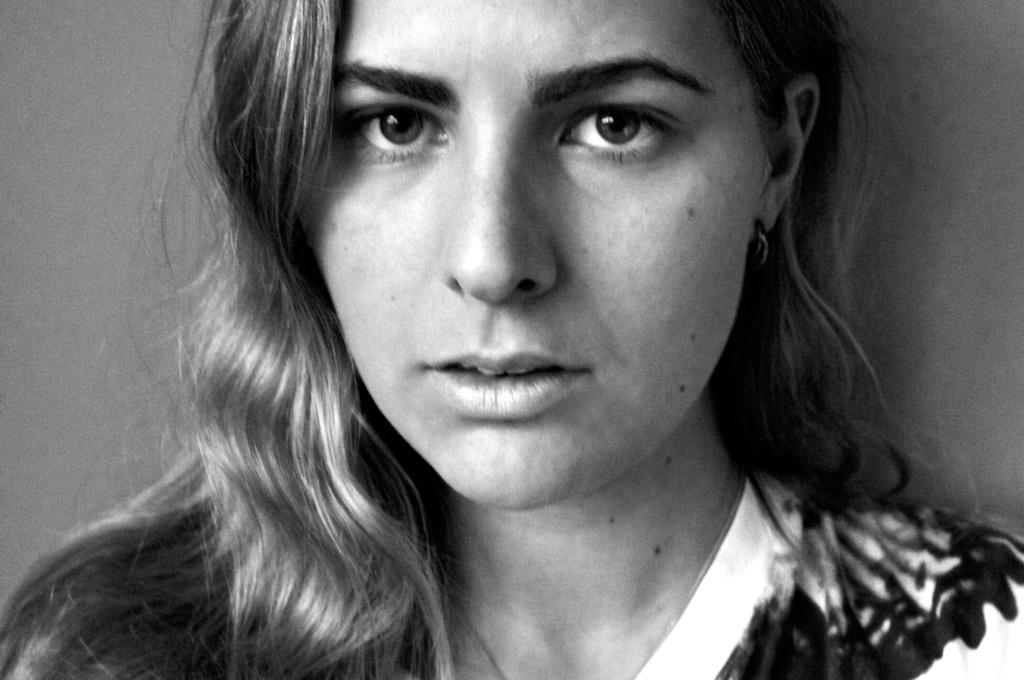What is the main subject of the image? The main subject of the image is a woman's face. What specific features can be observed on the woman's face and neck? The woman has moles on her face and neck. What can be seen behind the woman in the image? The background of the image includes a wall. How is the image presented in terms of color? The photography is in black and white. What type of lock can be seen on the sidewalk in the image? There is no lock or sidewalk present in the image; it features a woman's face with moles and a wall in the background. Is the tramp visible in the image? There is no tramp present in the image. 